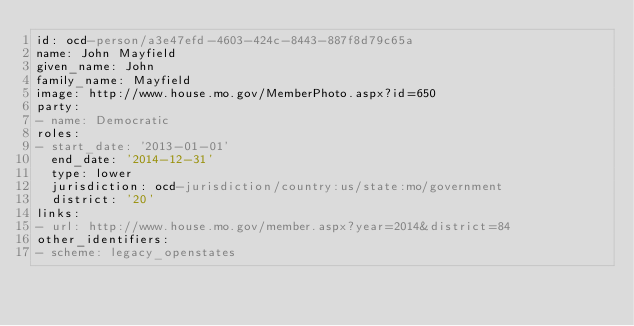<code> <loc_0><loc_0><loc_500><loc_500><_YAML_>id: ocd-person/a3e47efd-4603-424c-8443-887f8d79c65a
name: John Mayfield
given_name: John
family_name: Mayfield
image: http://www.house.mo.gov/MemberPhoto.aspx?id=650
party:
- name: Democratic
roles:
- start_date: '2013-01-01'
  end_date: '2014-12-31'
  type: lower
  jurisdiction: ocd-jurisdiction/country:us/state:mo/government
  district: '20'
links:
- url: http://www.house.mo.gov/member.aspx?year=2014&district=84
other_identifiers:
- scheme: legacy_openstates</code> 